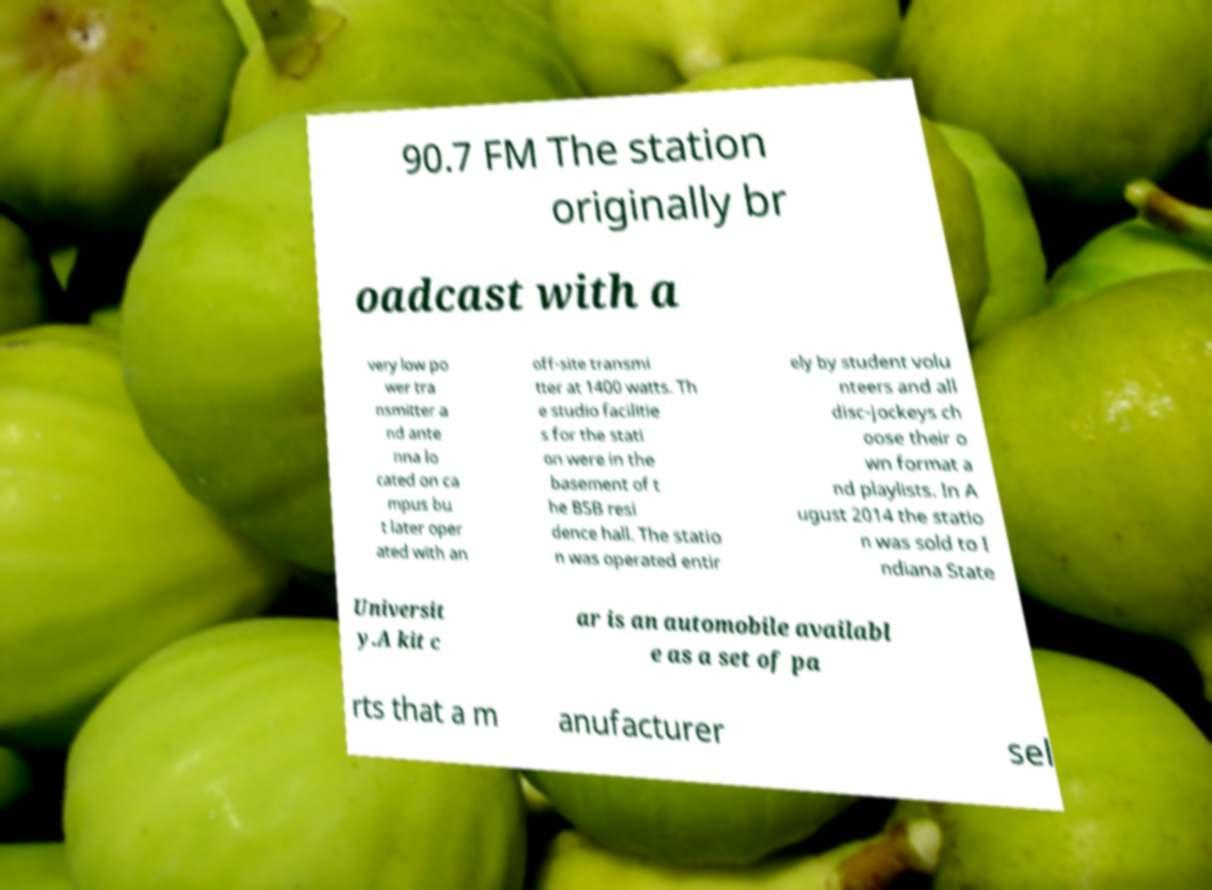What messages or text are displayed in this image? I need them in a readable, typed format. 90.7 FM The station originally br oadcast with a very low po wer tra nsmitter a nd ante nna lo cated on ca mpus bu t later oper ated with an off-site transmi tter at 1400 watts. Th e studio facilitie s for the stati on were in the basement of t he BSB resi dence hall. The statio n was operated entir ely by student volu nteers and all disc-jockeys ch oose their o wn format a nd playlists. In A ugust 2014 the statio n was sold to I ndiana State Universit y.A kit c ar is an automobile availabl e as a set of pa rts that a m anufacturer sel 